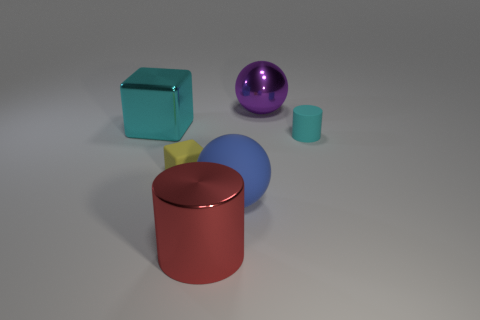What materials do the objects in the image appear to be made of? The objects in the image seem to be made of different materials. The large red cylinder and the blue sphere exhibit a reflective surface which suggests they are made of a polished metal. The purple sphere appears to be shiny and could be made of a polished metal or a resin, while the dark teal cube and the small cyan cylinder, although less reflective, still have a smooth surface that implies they might be made of plastic. 